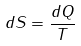<formula> <loc_0><loc_0><loc_500><loc_500>d S = \frac { d Q } { T }</formula> 